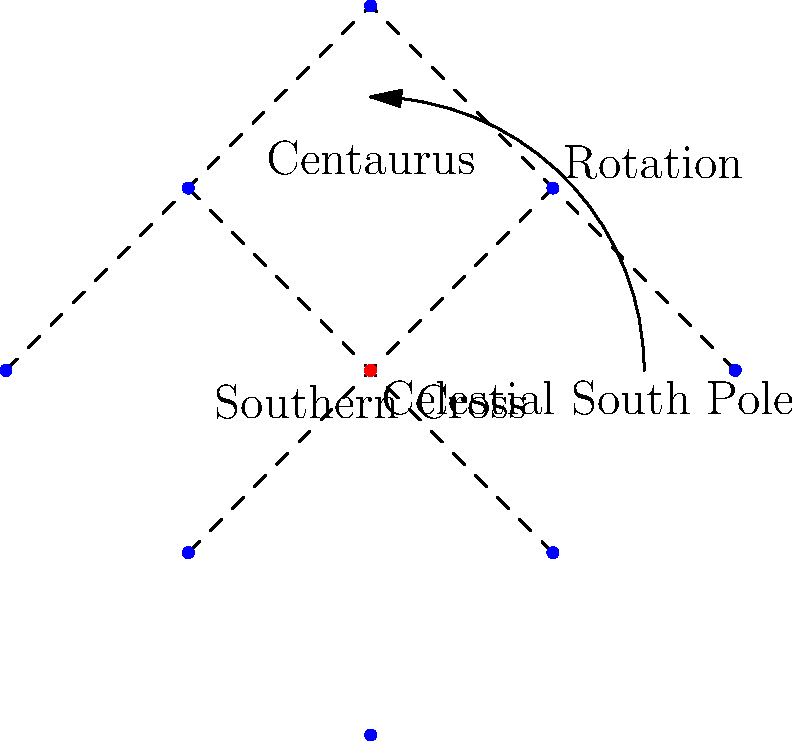In the star chart of the Southern Hemisphere shown above, which constellation appears to rotate around the celestial south pole and is often used for navigation? To answer this question, let's analyze the star chart step-by-step:

1. The chart shows two main constellations: the Southern Cross and Centaurus.

2. The Southern Cross is represented by four bright stars forming a cross-like shape near the center of the chart.

3. Centaurus is shown as a larger constellation with three main stars forming a triangle shape.

4. The celestial south pole is marked with a red dot at the center of the chart.

5. An arrow indicates the direction of rotation around the celestial south pole.

6. The Southern Cross is positioned closer to the celestial south pole than Centaurus.

7. Due to its proximity to the celestial south pole, the Southern Cross appears to rotate around it as the Earth rotates.

8. This rotation makes the Southern Cross a valuable tool for navigation in the Southern Hemisphere, as it can be used to locate the celestial south pole and, by extension, determine the direction of true south.

Given these observations, the constellation that appears to rotate around the celestial south pole and is often used for navigation is the Southern Cross.
Answer: Southern Cross 